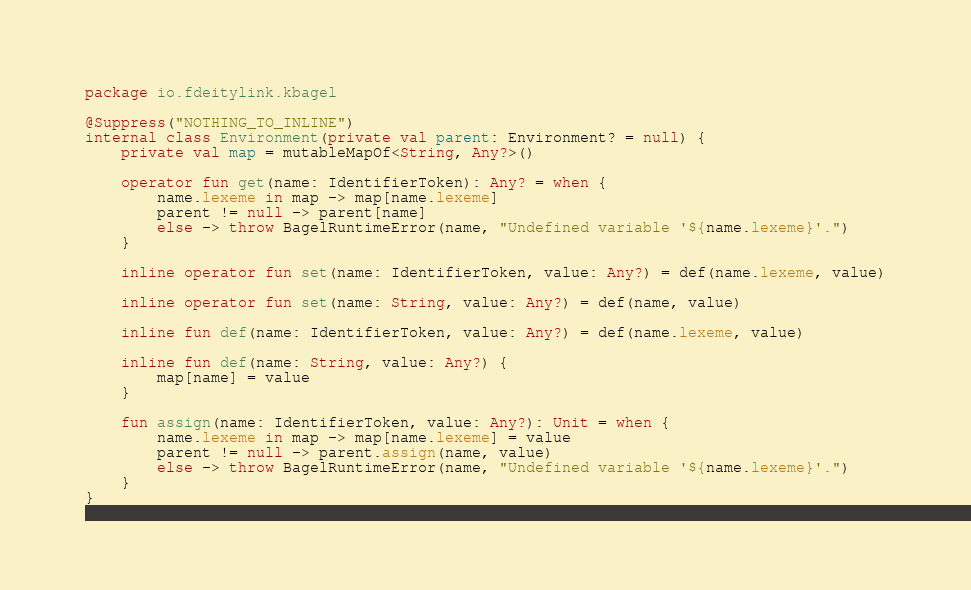<code> <loc_0><loc_0><loc_500><loc_500><_Kotlin_>package io.fdeitylink.kbagel

@Suppress("NOTHING_TO_INLINE")
internal class Environment(private val parent: Environment? = null) {
    private val map = mutableMapOf<String, Any?>()

    operator fun get(name: IdentifierToken): Any? = when {
        name.lexeme in map -> map[name.lexeme]
        parent != null -> parent[name]
        else -> throw BagelRuntimeError(name, "Undefined variable '${name.lexeme}'.")
    }

    inline operator fun set(name: IdentifierToken, value: Any?) = def(name.lexeme, value)

    inline operator fun set(name: String, value: Any?) = def(name, value)

    inline fun def(name: IdentifierToken, value: Any?) = def(name.lexeme, value)

    inline fun def(name: String, value: Any?) {
        map[name] = value
    }

    fun assign(name: IdentifierToken, value: Any?): Unit = when {
        name.lexeme in map -> map[name.lexeme] = value
        parent != null -> parent.assign(name, value)
        else -> throw BagelRuntimeError(name, "Undefined variable '${name.lexeme}'.")
    }
}</code> 